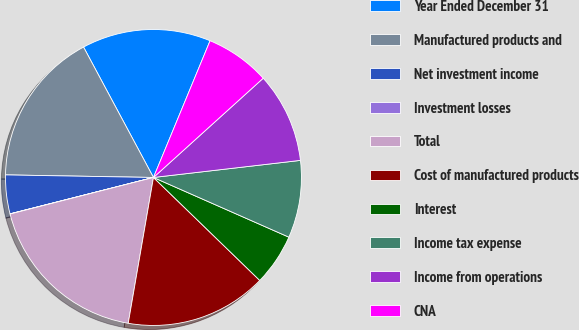<chart> <loc_0><loc_0><loc_500><loc_500><pie_chart><fcel>Year Ended December 31<fcel>Manufactured products and<fcel>Net investment income<fcel>Investment losses<fcel>Total<fcel>Cost of manufactured products<fcel>Interest<fcel>Income tax expense<fcel>Income from operations<fcel>CNA<nl><fcel>14.08%<fcel>16.89%<fcel>4.23%<fcel>0.02%<fcel>18.3%<fcel>15.48%<fcel>5.64%<fcel>8.45%<fcel>9.86%<fcel>7.05%<nl></chart> 